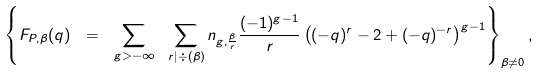<formula> <loc_0><loc_0><loc_500><loc_500>\left \{ F _ { P , \beta } ( q ) \ = \ \sum _ { g > - \infty } \ \sum _ { r | \div ( \beta ) } n _ { g , \frac { \beta } r } \frac { ( - 1 ) ^ { g - 1 } } r \left ( ( - q ) ^ { r } - 2 + ( - q ) ^ { - r } \right ) ^ { g - 1 } \right \} _ { \beta \neq 0 } ,</formula> 